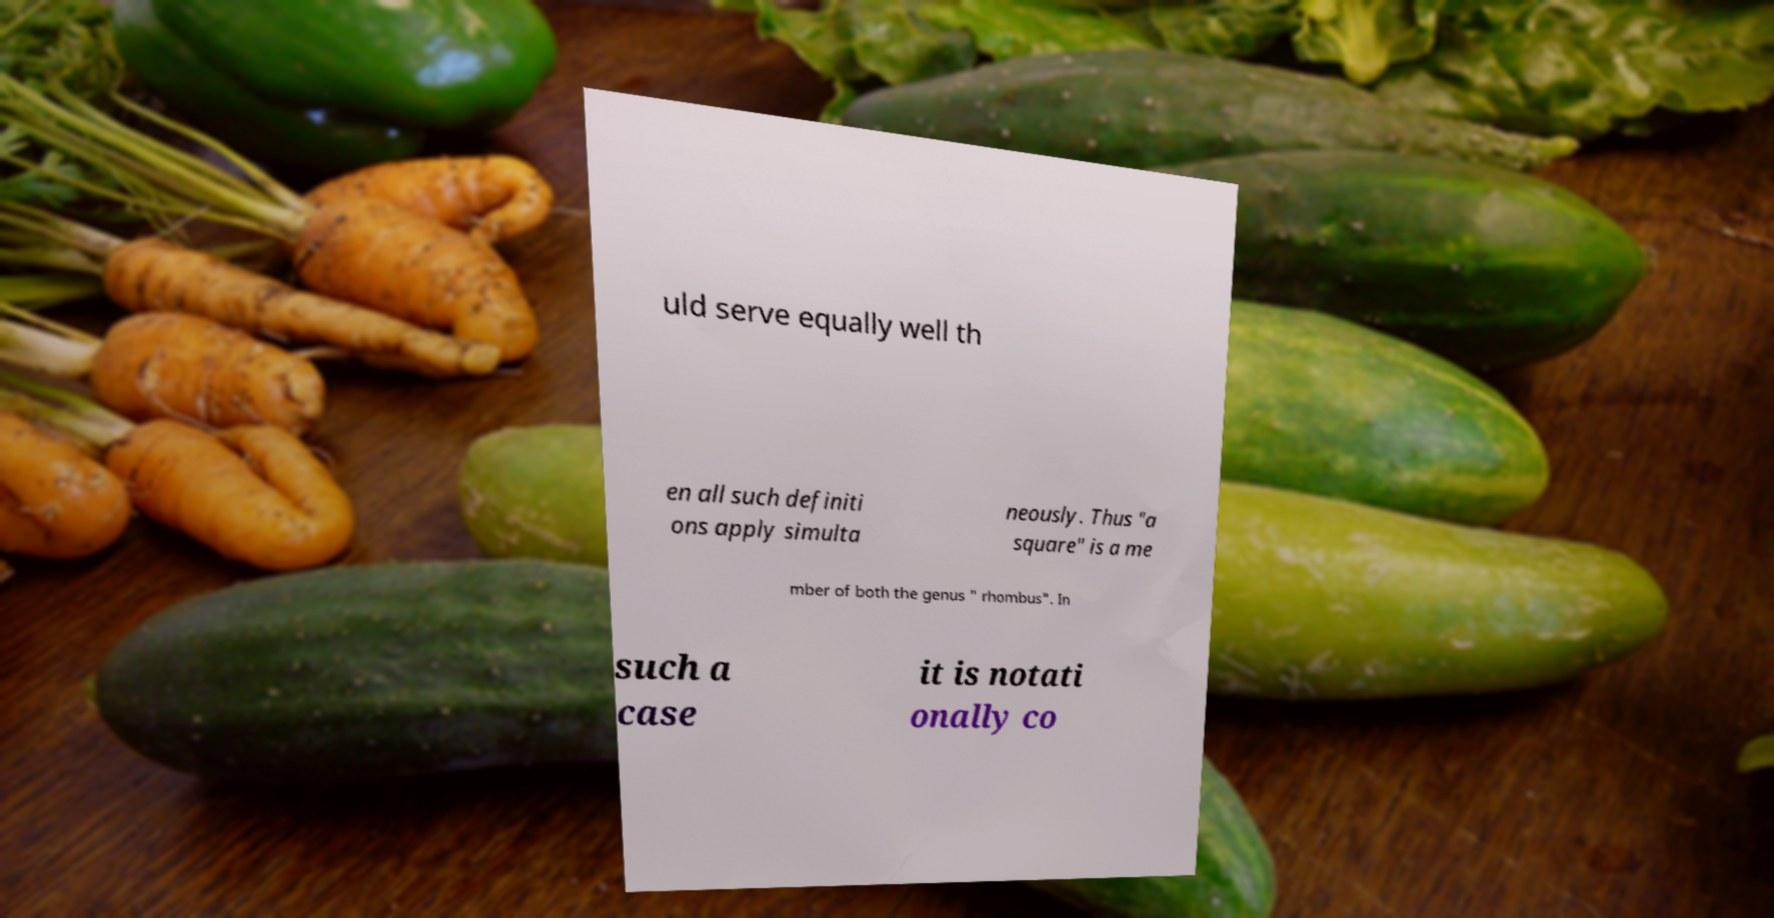For documentation purposes, I need the text within this image transcribed. Could you provide that? uld serve equally well th en all such definiti ons apply simulta neously. Thus "a square" is a me mber of both the genus " rhombus". In such a case it is notati onally co 